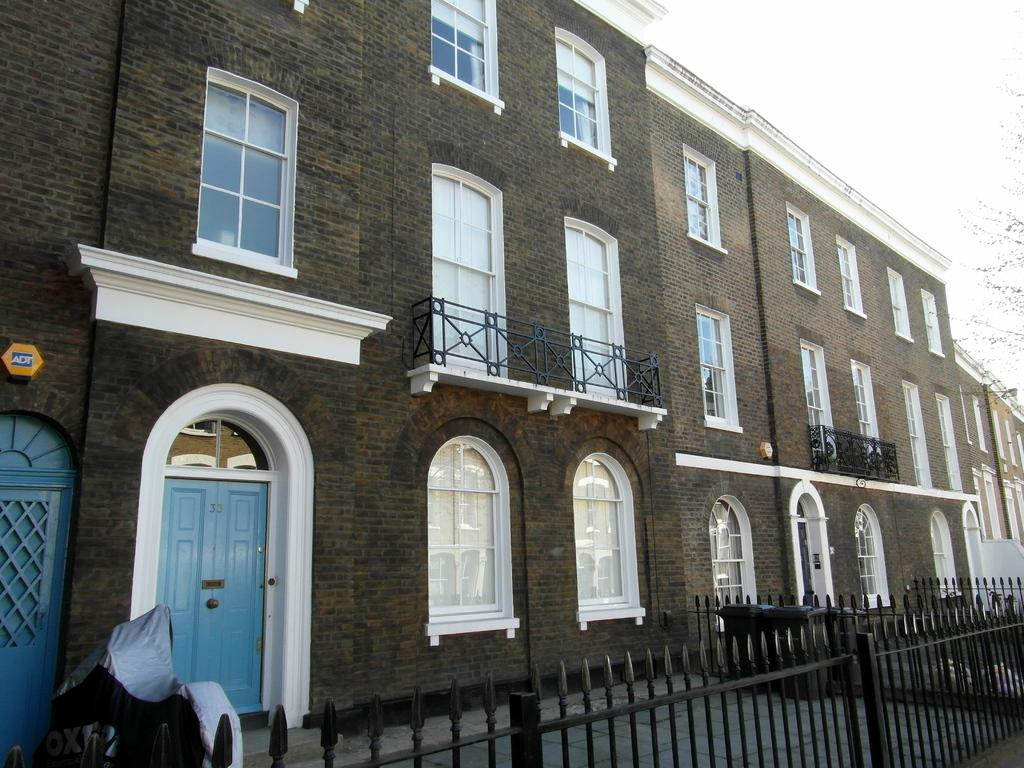What type of structure is visible in the image? There is a building in the image. What is located in front of the building? There is an object covered with cloth in front of the building. What feature can be seen near the building? There is a railing in the image. What can be seen in the background of the image? The sky is visible in the background of the image. What type of collar is visible on the spy in the image? There is no spy or collar present in the image. How does the wash look in the image? There is no mention of a wash or any washing-related activity in the image. 